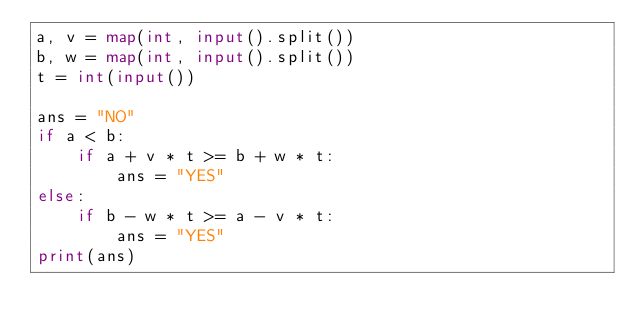Convert code to text. <code><loc_0><loc_0><loc_500><loc_500><_Python_>a, v = map(int, input().split())
b, w = map(int, input().split())
t = int(input())

ans = "NO"
if a < b:
    if a + v * t >= b + w * t:
        ans = "YES"
else:
    if b - w * t >= a - v * t:
        ans = "YES"
print(ans)
</code> 